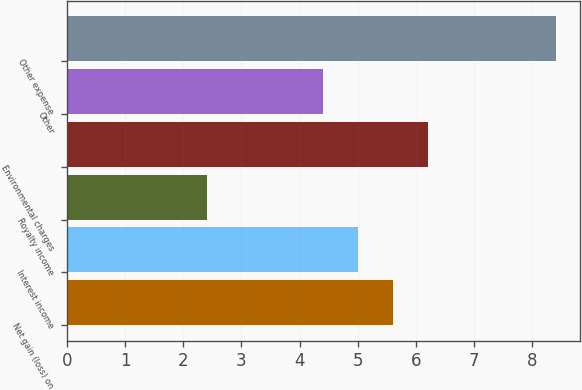Convert chart to OTSL. <chart><loc_0><loc_0><loc_500><loc_500><bar_chart><fcel>Net gain (loss) on<fcel>Interest income<fcel>Royalty income<fcel>Environmental charges<fcel>Other<fcel>Other expense<nl><fcel>5.6<fcel>5<fcel>2.4<fcel>6.2<fcel>4.4<fcel>8.4<nl></chart> 